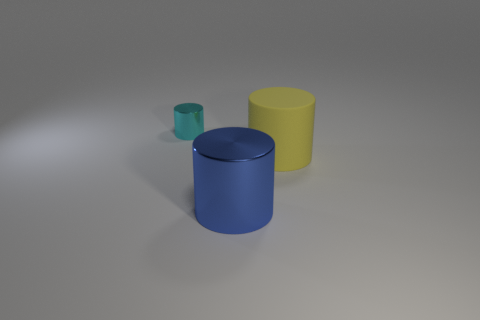Subtract all big cylinders. How many cylinders are left? 1 Add 1 metal cubes. How many objects exist? 4 Subtract all yellow cylinders. Subtract all yellow matte cylinders. How many objects are left? 1 Add 2 metal cylinders. How many metal cylinders are left? 4 Add 1 shiny blocks. How many shiny blocks exist? 1 Subtract 1 yellow cylinders. How many objects are left? 2 